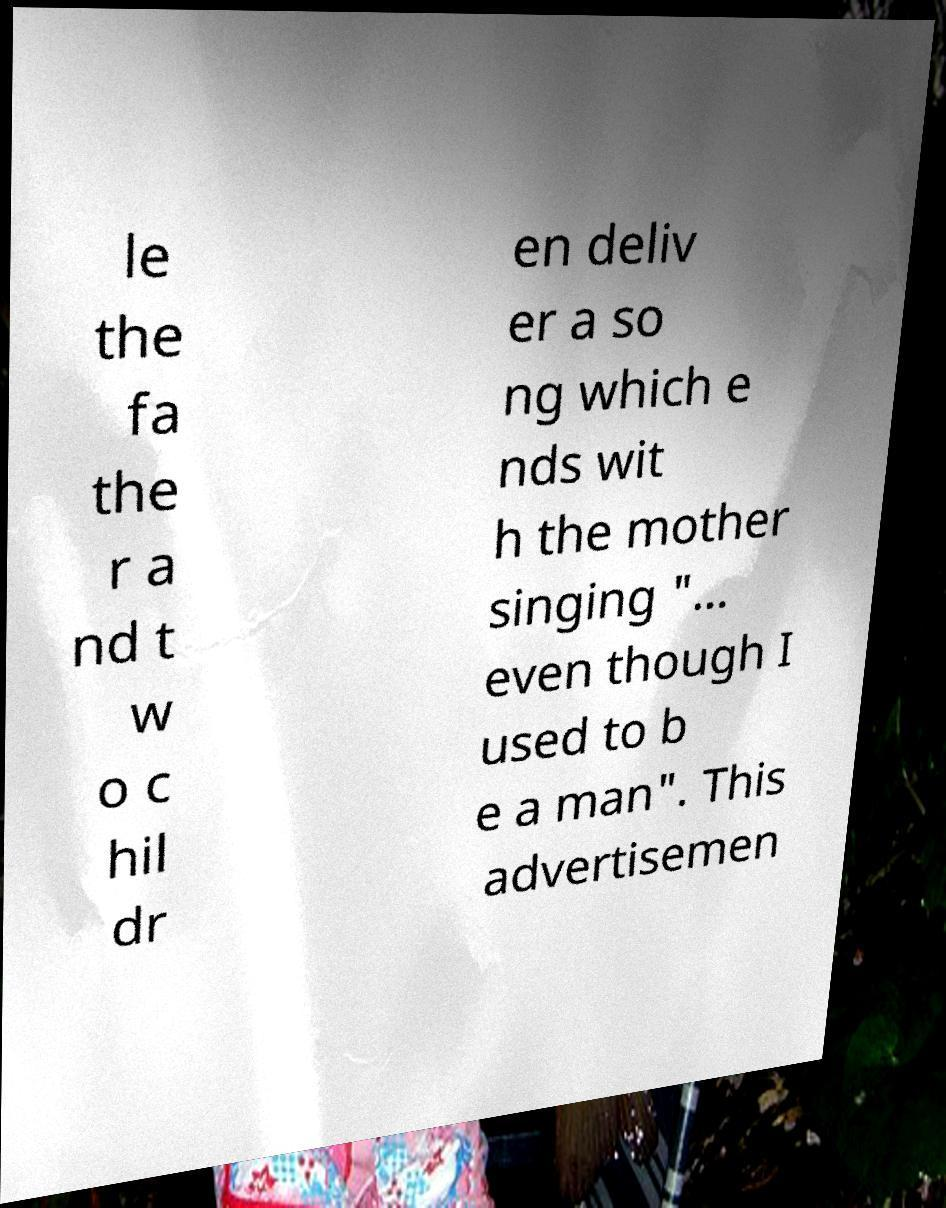What messages or text are displayed in this image? I need them in a readable, typed format. le the fa the r a nd t w o c hil dr en deliv er a so ng which e nds wit h the mother singing "... even though I used to b e a man". This advertisemen 